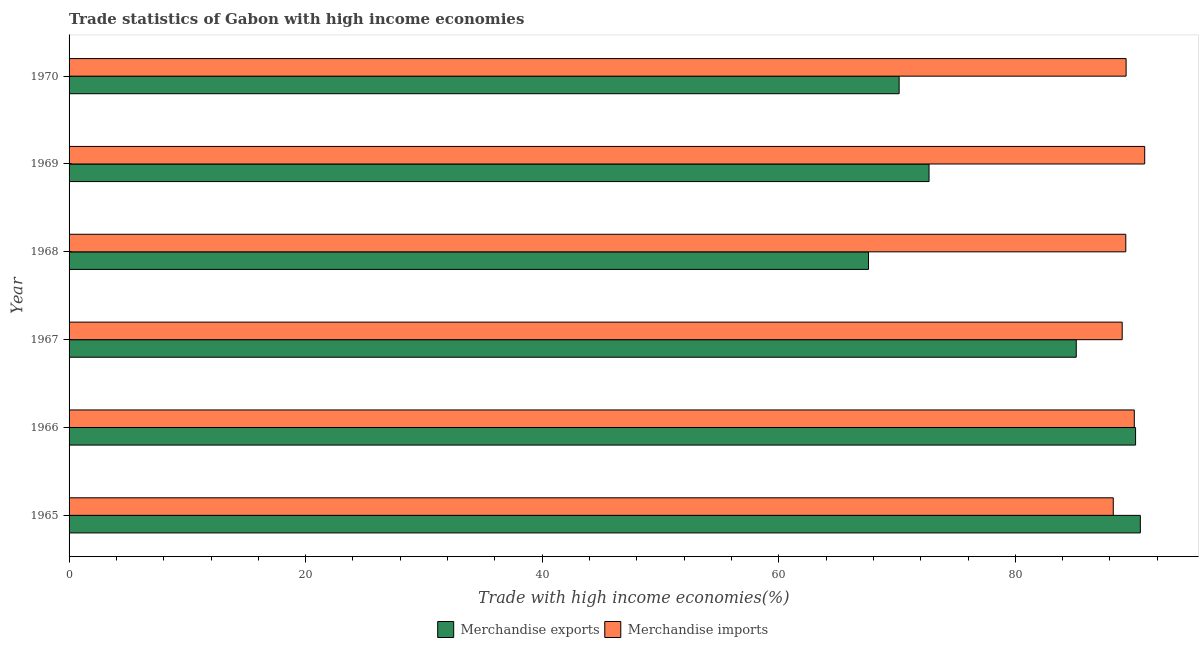How many different coloured bars are there?
Provide a succinct answer. 2. How many groups of bars are there?
Offer a terse response. 6. Are the number of bars per tick equal to the number of legend labels?
Your response must be concise. Yes. Are the number of bars on each tick of the Y-axis equal?
Offer a very short reply. Yes. How many bars are there on the 3rd tick from the bottom?
Keep it short and to the point. 2. What is the label of the 5th group of bars from the top?
Give a very brief answer. 1966. In how many cases, is the number of bars for a given year not equal to the number of legend labels?
Offer a terse response. 0. What is the merchandise imports in 1965?
Provide a succinct answer. 88.28. Across all years, what is the maximum merchandise exports?
Your answer should be compact. 90.57. Across all years, what is the minimum merchandise exports?
Ensure brevity in your answer.  67.59. In which year was the merchandise exports maximum?
Provide a succinct answer. 1965. In which year was the merchandise exports minimum?
Give a very brief answer. 1968. What is the total merchandise exports in the graph?
Ensure brevity in your answer.  476.37. What is the difference between the merchandise exports in 1967 and that in 1970?
Provide a short and direct response. 14.98. What is the difference between the merchandise imports in 1966 and the merchandise exports in 1970?
Make the answer very short. 19.88. What is the average merchandise imports per year?
Ensure brevity in your answer.  89.5. In the year 1966, what is the difference between the merchandise imports and merchandise exports?
Your answer should be compact. -0.11. In how many years, is the merchandise imports greater than 40 %?
Your response must be concise. 6. What is the ratio of the merchandise exports in 1966 to that in 1968?
Make the answer very short. 1.33. Is the merchandise imports in 1967 less than that in 1969?
Your response must be concise. Yes. What is the difference between the highest and the second highest merchandise imports?
Your answer should be very brief. 0.88. What is the difference between the highest and the lowest merchandise imports?
Offer a terse response. 2.66. In how many years, is the merchandise imports greater than the average merchandise imports taken over all years?
Ensure brevity in your answer.  2. Are all the bars in the graph horizontal?
Your answer should be very brief. Yes. How many years are there in the graph?
Provide a succinct answer. 6. What is the difference between two consecutive major ticks on the X-axis?
Your answer should be very brief. 20. Where does the legend appear in the graph?
Ensure brevity in your answer.  Bottom center. How many legend labels are there?
Your answer should be compact. 2. How are the legend labels stacked?
Provide a short and direct response. Horizontal. What is the title of the graph?
Provide a short and direct response. Trade statistics of Gabon with high income economies. Does "Merchandise imports" appear as one of the legend labels in the graph?
Your answer should be compact. Yes. What is the label or title of the X-axis?
Your answer should be compact. Trade with high income economies(%). What is the label or title of the Y-axis?
Offer a terse response. Year. What is the Trade with high income economies(%) in Merchandise exports in 1965?
Keep it short and to the point. 90.57. What is the Trade with high income economies(%) of Merchandise imports in 1965?
Keep it short and to the point. 88.28. What is the Trade with high income economies(%) in Merchandise exports in 1966?
Keep it short and to the point. 90.17. What is the Trade with high income economies(%) of Merchandise imports in 1966?
Give a very brief answer. 90.06. What is the Trade with high income economies(%) in Merchandise exports in 1967?
Ensure brevity in your answer.  85.15. What is the Trade with high income economies(%) of Merchandise imports in 1967?
Your answer should be very brief. 89.04. What is the Trade with high income economies(%) of Merchandise exports in 1968?
Your answer should be compact. 67.59. What is the Trade with high income economies(%) in Merchandise imports in 1968?
Offer a terse response. 89.34. What is the Trade with high income economies(%) in Merchandise exports in 1969?
Offer a very short reply. 72.71. What is the Trade with high income economies(%) in Merchandise imports in 1969?
Make the answer very short. 90.94. What is the Trade with high income economies(%) of Merchandise exports in 1970?
Your answer should be very brief. 70.18. What is the Trade with high income economies(%) of Merchandise imports in 1970?
Provide a succinct answer. 89.37. Across all years, what is the maximum Trade with high income economies(%) of Merchandise exports?
Offer a very short reply. 90.57. Across all years, what is the maximum Trade with high income economies(%) in Merchandise imports?
Your response must be concise. 90.94. Across all years, what is the minimum Trade with high income economies(%) of Merchandise exports?
Give a very brief answer. 67.59. Across all years, what is the minimum Trade with high income economies(%) in Merchandise imports?
Your answer should be compact. 88.28. What is the total Trade with high income economies(%) of Merchandise exports in the graph?
Your response must be concise. 476.37. What is the total Trade with high income economies(%) of Merchandise imports in the graph?
Ensure brevity in your answer.  537.03. What is the difference between the Trade with high income economies(%) in Merchandise exports in 1965 and that in 1966?
Your answer should be very brief. 0.4. What is the difference between the Trade with high income economies(%) of Merchandise imports in 1965 and that in 1966?
Provide a succinct answer. -1.78. What is the difference between the Trade with high income economies(%) in Merchandise exports in 1965 and that in 1967?
Offer a very short reply. 5.42. What is the difference between the Trade with high income economies(%) of Merchandise imports in 1965 and that in 1967?
Make the answer very short. -0.75. What is the difference between the Trade with high income economies(%) in Merchandise exports in 1965 and that in 1968?
Keep it short and to the point. 22.98. What is the difference between the Trade with high income economies(%) of Merchandise imports in 1965 and that in 1968?
Your response must be concise. -1.06. What is the difference between the Trade with high income economies(%) in Merchandise exports in 1965 and that in 1969?
Your response must be concise. 17.86. What is the difference between the Trade with high income economies(%) of Merchandise imports in 1965 and that in 1969?
Provide a succinct answer. -2.66. What is the difference between the Trade with high income economies(%) in Merchandise exports in 1965 and that in 1970?
Provide a succinct answer. 20.39. What is the difference between the Trade with high income economies(%) of Merchandise imports in 1965 and that in 1970?
Keep it short and to the point. -1.09. What is the difference between the Trade with high income economies(%) of Merchandise exports in 1966 and that in 1967?
Ensure brevity in your answer.  5.01. What is the difference between the Trade with high income economies(%) of Merchandise imports in 1966 and that in 1967?
Make the answer very short. 1.02. What is the difference between the Trade with high income economies(%) in Merchandise exports in 1966 and that in 1968?
Ensure brevity in your answer.  22.58. What is the difference between the Trade with high income economies(%) in Merchandise imports in 1966 and that in 1968?
Offer a terse response. 0.72. What is the difference between the Trade with high income economies(%) in Merchandise exports in 1966 and that in 1969?
Keep it short and to the point. 17.46. What is the difference between the Trade with high income economies(%) of Merchandise imports in 1966 and that in 1969?
Provide a succinct answer. -0.88. What is the difference between the Trade with high income economies(%) in Merchandise exports in 1966 and that in 1970?
Make the answer very short. 19.99. What is the difference between the Trade with high income economies(%) of Merchandise imports in 1966 and that in 1970?
Give a very brief answer. 0.69. What is the difference between the Trade with high income economies(%) in Merchandise exports in 1967 and that in 1968?
Keep it short and to the point. 17.57. What is the difference between the Trade with high income economies(%) in Merchandise imports in 1967 and that in 1968?
Your answer should be compact. -0.3. What is the difference between the Trade with high income economies(%) in Merchandise exports in 1967 and that in 1969?
Offer a very short reply. 12.45. What is the difference between the Trade with high income economies(%) in Merchandise imports in 1967 and that in 1969?
Ensure brevity in your answer.  -1.9. What is the difference between the Trade with high income economies(%) in Merchandise exports in 1967 and that in 1970?
Keep it short and to the point. 14.98. What is the difference between the Trade with high income economies(%) in Merchandise imports in 1967 and that in 1970?
Your response must be concise. -0.33. What is the difference between the Trade with high income economies(%) in Merchandise exports in 1968 and that in 1969?
Your answer should be very brief. -5.12. What is the difference between the Trade with high income economies(%) of Merchandise imports in 1968 and that in 1969?
Make the answer very short. -1.6. What is the difference between the Trade with high income economies(%) of Merchandise exports in 1968 and that in 1970?
Keep it short and to the point. -2.59. What is the difference between the Trade with high income economies(%) of Merchandise imports in 1968 and that in 1970?
Your answer should be very brief. -0.03. What is the difference between the Trade with high income economies(%) in Merchandise exports in 1969 and that in 1970?
Your answer should be compact. 2.53. What is the difference between the Trade with high income economies(%) in Merchandise imports in 1969 and that in 1970?
Make the answer very short. 1.57. What is the difference between the Trade with high income economies(%) in Merchandise exports in 1965 and the Trade with high income economies(%) in Merchandise imports in 1966?
Your response must be concise. 0.51. What is the difference between the Trade with high income economies(%) of Merchandise exports in 1965 and the Trade with high income economies(%) of Merchandise imports in 1967?
Your response must be concise. 1.53. What is the difference between the Trade with high income economies(%) in Merchandise exports in 1965 and the Trade with high income economies(%) in Merchandise imports in 1968?
Your response must be concise. 1.23. What is the difference between the Trade with high income economies(%) of Merchandise exports in 1965 and the Trade with high income economies(%) of Merchandise imports in 1969?
Provide a short and direct response. -0.37. What is the difference between the Trade with high income economies(%) in Merchandise exports in 1965 and the Trade with high income economies(%) in Merchandise imports in 1970?
Provide a short and direct response. 1.2. What is the difference between the Trade with high income economies(%) of Merchandise exports in 1966 and the Trade with high income economies(%) of Merchandise imports in 1967?
Your answer should be compact. 1.13. What is the difference between the Trade with high income economies(%) of Merchandise exports in 1966 and the Trade with high income economies(%) of Merchandise imports in 1968?
Ensure brevity in your answer.  0.83. What is the difference between the Trade with high income economies(%) of Merchandise exports in 1966 and the Trade with high income economies(%) of Merchandise imports in 1969?
Offer a very short reply. -0.77. What is the difference between the Trade with high income economies(%) of Merchandise exports in 1966 and the Trade with high income economies(%) of Merchandise imports in 1970?
Make the answer very short. 0.8. What is the difference between the Trade with high income economies(%) in Merchandise exports in 1967 and the Trade with high income economies(%) in Merchandise imports in 1968?
Provide a short and direct response. -4.19. What is the difference between the Trade with high income economies(%) in Merchandise exports in 1967 and the Trade with high income economies(%) in Merchandise imports in 1969?
Ensure brevity in your answer.  -5.79. What is the difference between the Trade with high income economies(%) in Merchandise exports in 1967 and the Trade with high income economies(%) in Merchandise imports in 1970?
Ensure brevity in your answer.  -4.21. What is the difference between the Trade with high income economies(%) in Merchandise exports in 1968 and the Trade with high income economies(%) in Merchandise imports in 1969?
Give a very brief answer. -23.35. What is the difference between the Trade with high income economies(%) in Merchandise exports in 1968 and the Trade with high income economies(%) in Merchandise imports in 1970?
Ensure brevity in your answer.  -21.78. What is the difference between the Trade with high income economies(%) in Merchandise exports in 1969 and the Trade with high income economies(%) in Merchandise imports in 1970?
Your answer should be compact. -16.66. What is the average Trade with high income economies(%) in Merchandise exports per year?
Make the answer very short. 79.39. What is the average Trade with high income economies(%) of Merchandise imports per year?
Provide a succinct answer. 89.5. In the year 1965, what is the difference between the Trade with high income economies(%) of Merchandise exports and Trade with high income economies(%) of Merchandise imports?
Make the answer very short. 2.29. In the year 1966, what is the difference between the Trade with high income economies(%) of Merchandise exports and Trade with high income economies(%) of Merchandise imports?
Make the answer very short. 0.11. In the year 1967, what is the difference between the Trade with high income economies(%) of Merchandise exports and Trade with high income economies(%) of Merchandise imports?
Ensure brevity in your answer.  -3.88. In the year 1968, what is the difference between the Trade with high income economies(%) of Merchandise exports and Trade with high income economies(%) of Merchandise imports?
Give a very brief answer. -21.75. In the year 1969, what is the difference between the Trade with high income economies(%) in Merchandise exports and Trade with high income economies(%) in Merchandise imports?
Your response must be concise. -18.23. In the year 1970, what is the difference between the Trade with high income economies(%) of Merchandise exports and Trade with high income economies(%) of Merchandise imports?
Your response must be concise. -19.19. What is the ratio of the Trade with high income economies(%) of Merchandise imports in 1965 to that in 1966?
Offer a terse response. 0.98. What is the ratio of the Trade with high income economies(%) in Merchandise exports in 1965 to that in 1967?
Keep it short and to the point. 1.06. What is the ratio of the Trade with high income economies(%) in Merchandise imports in 1965 to that in 1967?
Provide a short and direct response. 0.99. What is the ratio of the Trade with high income economies(%) of Merchandise exports in 1965 to that in 1968?
Keep it short and to the point. 1.34. What is the ratio of the Trade with high income economies(%) of Merchandise exports in 1965 to that in 1969?
Offer a very short reply. 1.25. What is the ratio of the Trade with high income economies(%) of Merchandise imports in 1965 to that in 1969?
Your response must be concise. 0.97. What is the ratio of the Trade with high income economies(%) in Merchandise exports in 1965 to that in 1970?
Offer a very short reply. 1.29. What is the ratio of the Trade with high income economies(%) in Merchandise imports in 1965 to that in 1970?
Ensure brevity in your answer.  0.99. What is the ratio of the Trade with high income economies(%) of Merchandise exports in 1966 to that in 1967?
Your answer should be very brief. 1.06. What is the ratio of the Trade with high income economies(%) in Merchandise imports in 1966 to that in 1967?
Give a very brief answer. 1.01. What is the ratio of the Trade with high income economies(%) of Merchandise exports in 1966 to that in 1968?
Provide a succinct answer. 1.33. What is the ratio of the Trade with high income economies(%) in Merchandise exports in 1966 to that in 1969?
Your answer should be very brief. 1.24. What is the ratio of the Trade with high income economies(%) of Merchandise imports in 1966 to that in 1969?
Provide a succinct answer. 0.99. What is the ratio of the Trade with high income economies(%) of Merchandise exports in 1966 to that in 1970?
Provide a succinct answer. 1.28. What is the ratio of the Trade with high income economies(%) of Merchandise imports in 1966 to that in 1970?
Offer a very short reply. 1.01. What is the ratio of the Trade with high income economies(%) in Merchandise exports in 1967 to that in 1968?
Your answer should be compact. 1.26. What is the ratio of the Trade with high income economies(%) of Merchandise imports in 1967 to that in 1968?
Your answer should be very brief. 1. What is the ratio of the Trade with high income economies(%) in Merchandise exports in 1967 to that in 1969?
Keep it short and to the point. 1.17. What is the ratio of the Trade with high income economies(%) of Merchandise imports in 1967 to that in 1969?
Ensure brevity in your answer.  0.98. What is the ratio of the Trade with high income economies(%) of Merchandise exports in 1967 to that in 1970?
Make the answer very short. 1.21. What is the ratio of the Trade with high income economies(%) in Merchandise exports in 1968 to that in 1969?
Offer a very short reply. 0.93. What is the ratio of the Trade with high income economies(%) in Merchandise imports in 1968 to that in 1969?
Offer a very short reply. 0.98. What is the ratio of the Trade with high income economies(%) of Merchandise exports in 1968 to that in 1970?
Provide a short and direct response. 0.96. What is the ratio of the Trade with high income economies(%) in Merchandise imports in 1968 to that in 1970?
Your answer should be very brief. 1. What is the ratio of the Trade with high income economies(%) of Merchandise exports in 1969 to that in 1970?
Make the answer very short. 1.04. What is the ratio of the Trade with high income economies(%) in Merchandise imports in 1969 to that in 1970?
Ensure brevity in your answer.  1.02. What is the difference between the highest and the second highest Trade with high income economies(%) in Merchandise exports?
Give a very brief answer. 0.4. What is the difference between the highest and the second highest Trade with high income economies(%) in Merchandise imports?
Your answer should be compact. 0.88. What is the difference between the highest and the lowest Trade with high income economies(%) of Merchandise exports?
Your answer should be compact. 22.98. What is the difference between the highest and the lowest Trade with high income economies(%) in Merchandise imports?
Offer a terse response. 2.66. 